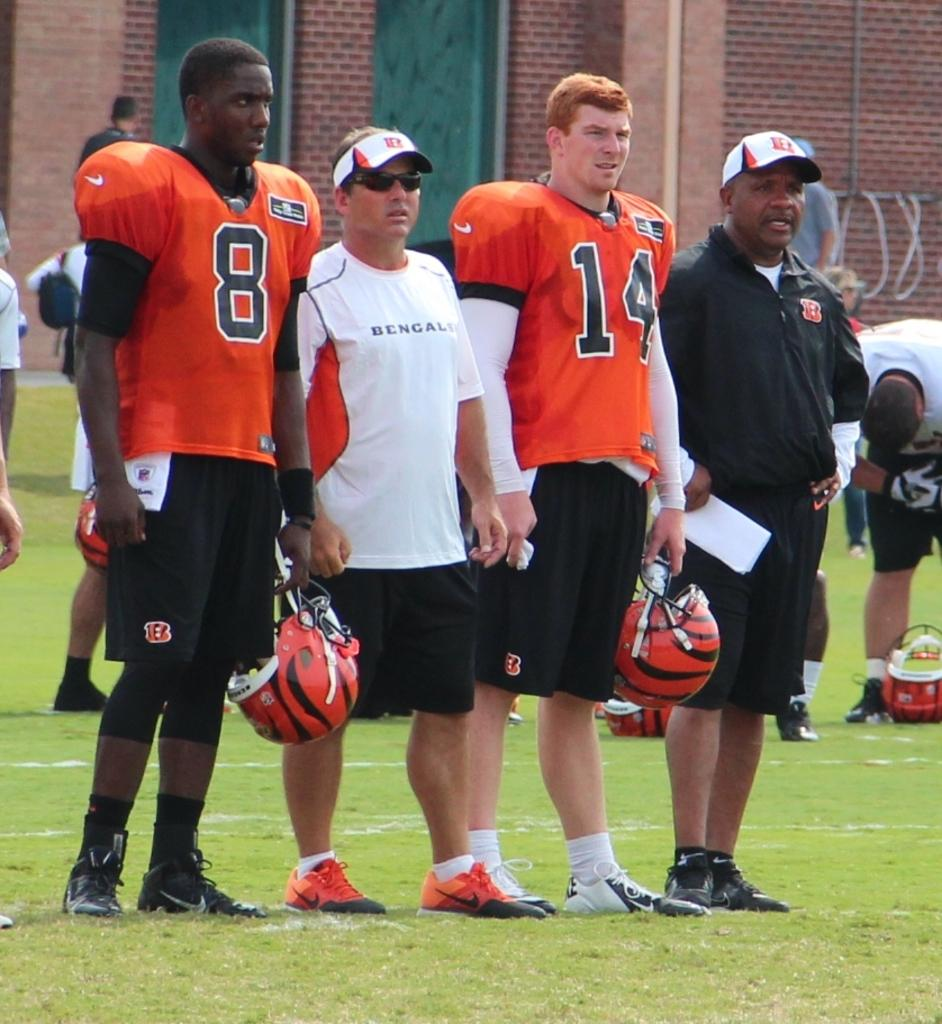What is the surface that the people are standing on in the image? The people are standing on the grass in the image. What else can be seen in the image besides the people? There are objects in the image. What can be seen in the distance in the image? There is a building in the background of the image. What type of yak is present in the image? There is no yak present in the image. What design can be seen on the people's clothing in the image? The provided facts do not mention any specific design on the people's clothing. 